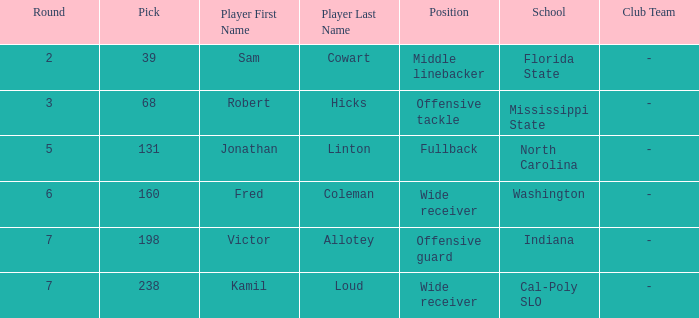Which Round has a School/Club Team of cal-poly slo, and a Pick smaller than 238? None. 